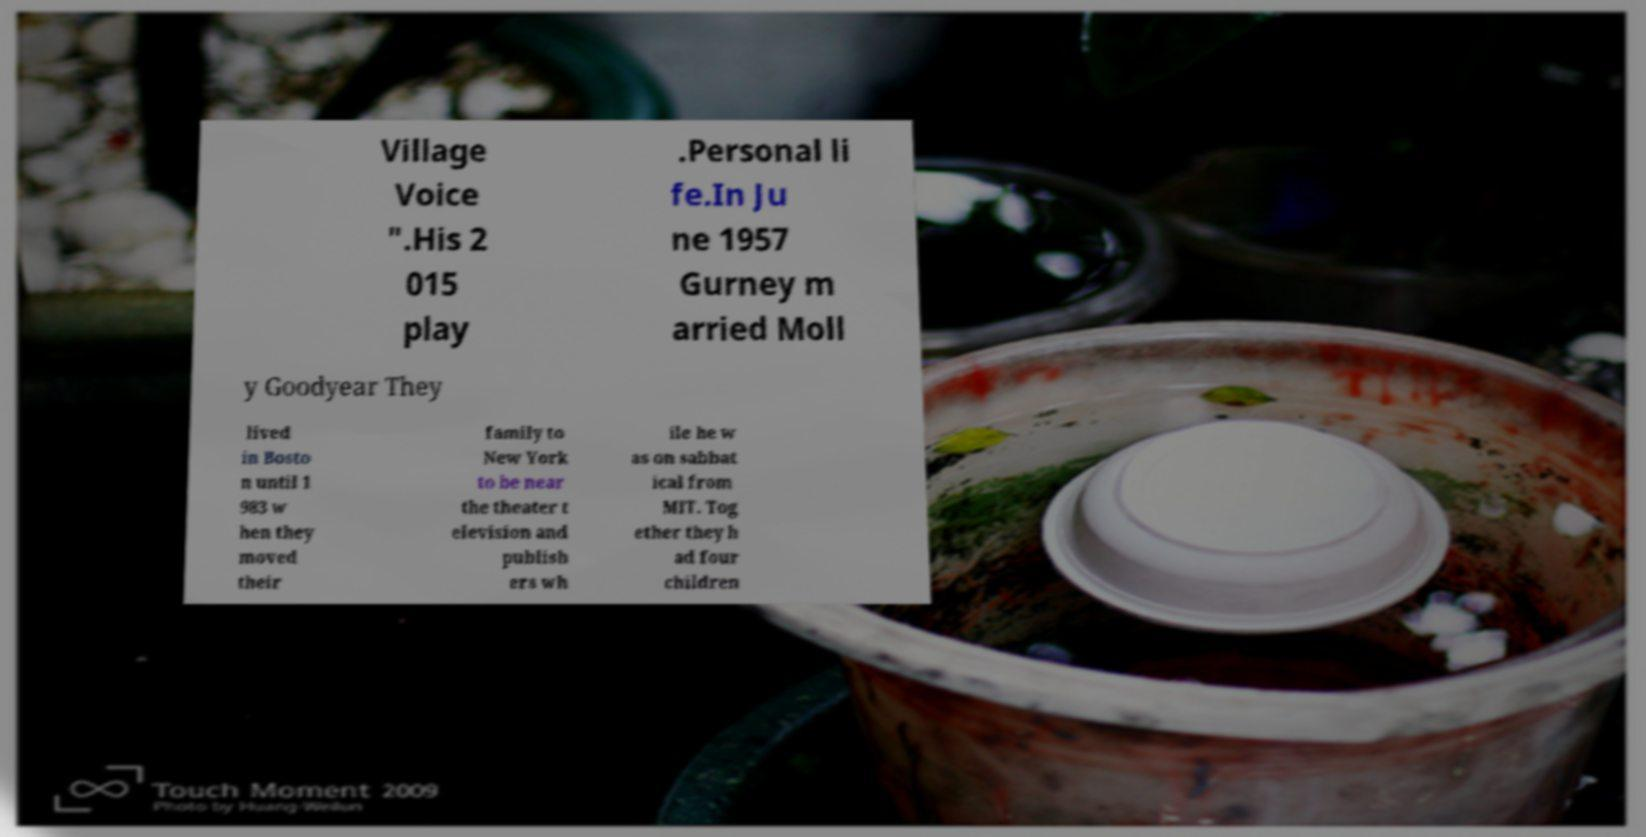For documentation purposes, I need the text within this image transcribed. Could you provide that? Village Voice ".His 2 015 play .Personal li fe.In Ju ne 1957 Gurney m arried Moll y Goodyear They lived in Bosto n until 1 983 w hen they moved their family to New York to be near the theater t elevision and publish ers wh ile he w as on sabbat ical from MIT. Tog ether they h ad four children 